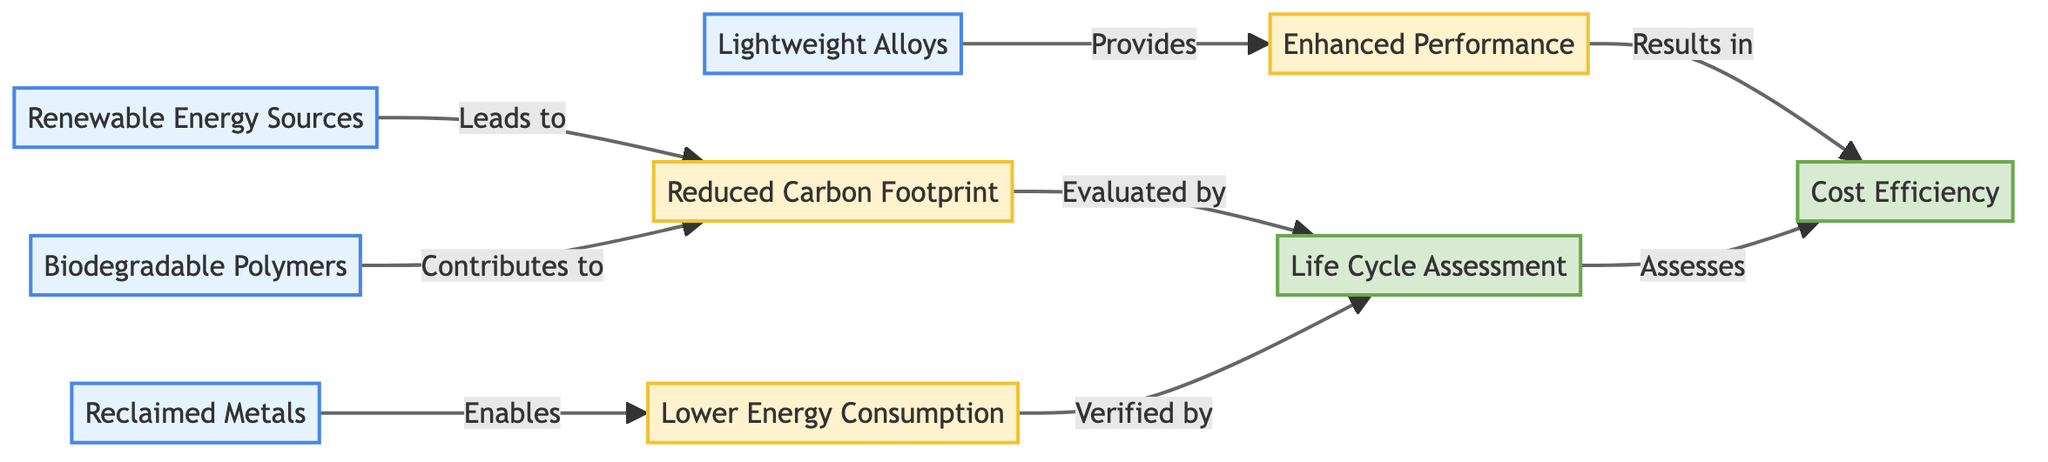What are the materials represented in the diagram? The diagram includes four materials: Renewable Energy Sources, Biodegradable Polymers, Reclaimed Metals, and Lightweight Alloys. These are identified as nodes within the diagram and are labeled clearly.
Answer: Renewable Energy Sources, Biodegradable Polymers, Reclaimed Metals, Lightweight Alloys Which outcome is linked to Lower Energy Consumption? The diagram shows that Lower Energy Consumption (LEC) is linked to Reduced Carbon Footprint (RCF). This is indicated by the arrow pointing from RCF to LEC in the flowchart.
Answer: Reduced Carbon Footprint How many outcomes are defined in the diagram? There are three outcomes defined in the diagram: Reduced Carbon Footprint, Lower Energy Consumption, and Enhanced Performance. This is confirmed by counting the outcome nodes present in the diagram.
Answer: Three What type of assessment is used to evaluate the outcomes? Life Cycle Assessment (LCA) is the type of assessment used to evaluate the outcomes. This is indicated by the arrows leading from the outcome nodes to the LCA node in the diagram.
Answer: Life Cycle Assessment Which material contributes to Reduced Carbon Footprint? The diagram illustrates that Biodegradable Polymers (BP) contribute to the Reduced Carbon Footprint. This relationship is directly represented by the arrow originating from the BP node pointing to the RCF node.
Answer: Biodegradable Polymers What does Enhanced Performance result in? According to the flowchart, Enhanced Performance (EP) results in Cost Efficiency (CE). This is shown by the arrow that leads from EP to CE, indicating a direct relationship between the two.
Answer: Cost Efficiency How many materials are there in total within the diagram? The total number of materials present in the diagram is four, which can be confirmed by counting the labeled material nodes.
Answer: Four What does Life Cycle Assessment assess? The Life Cycle Assessment (LCA) assesses Cost Efficiency (CE) as shown by the arrow connecting LCA to CE, indicating that LCA evaluates the impact on cost efficiency as part of the assessment process.
Answer: Cost Efficiency Which material enables Lower Energy Consumption? The diagram indicates that Reclaimed Metals (RM) enables Lower Energy Consumption (LEC), as represented by the direct arrow from RM to LEC.
Answer: Reclaimed Metals 